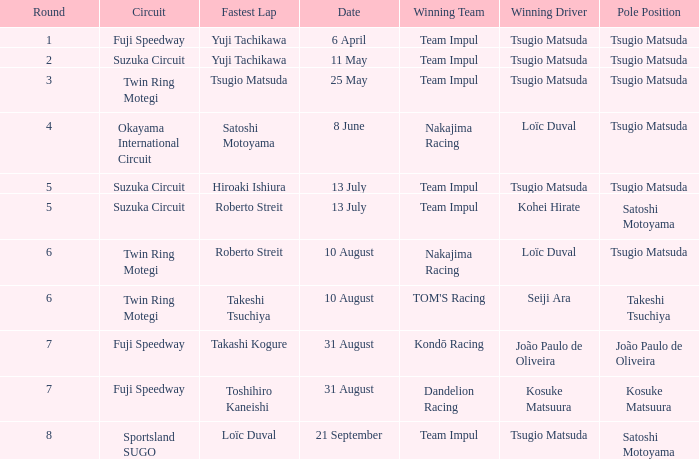Help me parse the entirety of this table. {'header': ['Round', 'Circuit', 'Fastest Lap', 'Date', 'Winning Team', 'Winning Driver', 'Pole Position'], 'rows': [['1', 'Fuji Speedway', 'Yuji Tachikawa', '6 April', 'Team Impul', 'Tsugio Matsuda', 'Tsugio Matsuda'], ['2', 'Suzuka Circuit', 'Yuji Tachikawa', '11 May', 'Team Impul', 'Tsugio Matsuda', 'Tsugio Matsuda'], ['3', 'Twin Ring Motegi', 'Tsugio Matsuda', '25 May', 'Team Impul', 'Tsugio Matsuda', 'Tsugio Matsuda'], ['4', 'Okayama International Circuit', 'Satoshi Motoyama', '8 June', 'Nakajima Racing', 'Loïc Duval', 'Tsugio Matsuda'], ['5', 'Suzuka Circuit', 'Hiroaki Ishiura', '13 July', 'Team Impul', 'Tsugio Matsuda', 'Tsugio Matsuda'], ['5', 'Suzuka Circuit', 'Roberto Streit', '13 July', 'Team Impul', 'Kohei Hirate', 'Satoshi Motoyama'], ['6', 'Twin Ring Motegi', 'Roberto Streit', '10 August', 'Nakajima Racing', 'Loïc Duval', 'Tsugio Matsuda'], ['6', 'Twin Ring Motegi', 'Takeshi Tsuchiya', '10 August', "TOM'S Racing", 'Seiji Ara', 'Takeshi Tsuchiya'], ['7', 'Fuji Speedway', 'Takashi Kogure', '31 August', 'Kondō Racing', 'João Paulo de Oliveira', 'João Paulo de Oliveira'], ['7', 'Fuji Speedway', 'Toshihiro Kaneishi', '31 August', 'Dandelion Racing', 'Kosuke Matsuura', 'Kosuke Matsuura'], ['8', 'Sportsland SUGO', 'Loïc Duval', '21 September', 'Team Impul', 'Tsugio Matsuda', 'Satoshi Motoyama']]} What is the fastest lap for Seiji Ara? Takeshi Tsuchiya. 